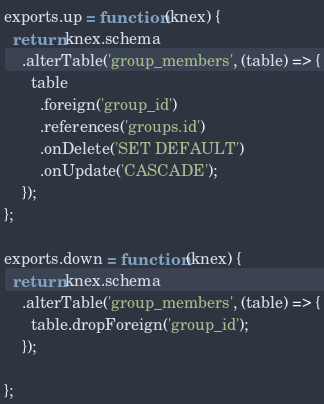Convert code to text. <code><loc_0><loc_0><loc_500><loc_500><_JavaScript_>
exports.up = function (knex) {
  return knex.schema
    .alterTable('group_members', (table) => {
      table
        .foreign('group_id')
        .references('groups.id')
        .onDelete('SET DEFAULT')
        .onUpdate('CASCADE');
    });
};

exports.down = function (knex) {
  return knex.schema
    .alterTable('group_members', (table) => {
      table.dropForeign('group_id');
    });

};
</code> 